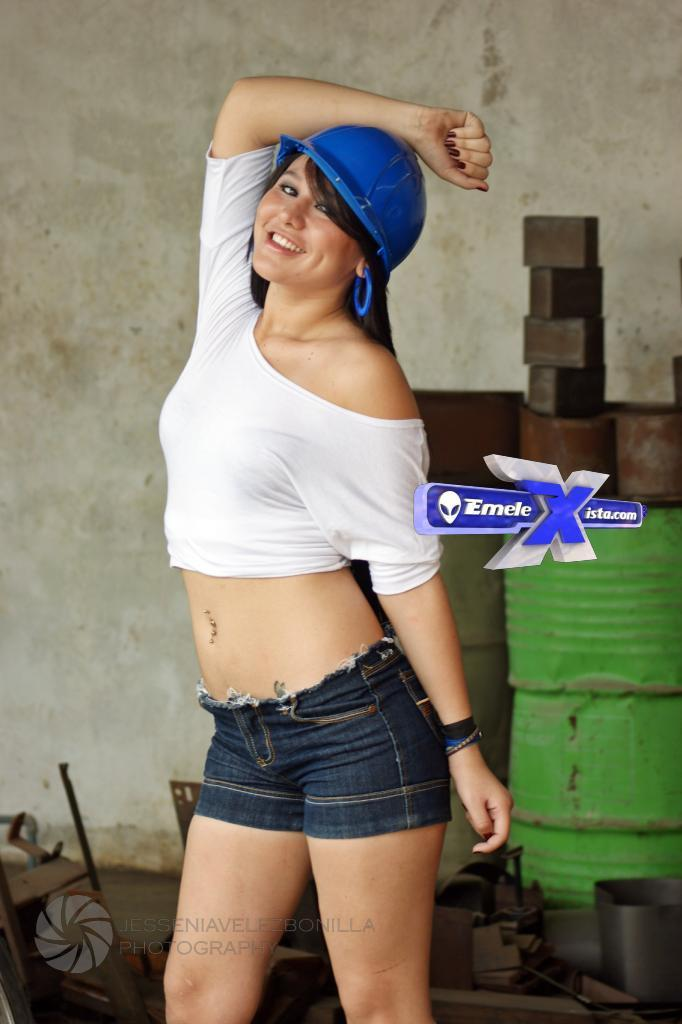Who is present in the image? There is a woman in the image. What is the woman's expression? The woman is smiling. What can be seen in the background of the image? There is a wall and objects in the background of the image. Are there any visible marks on the image? Yes, the image has watermarks. How many vases are present on the woman's head in the image? There are no vases present on the woman's head in the image. What day of the week is depicted in the image? The image does not depict a specific day of the week. 